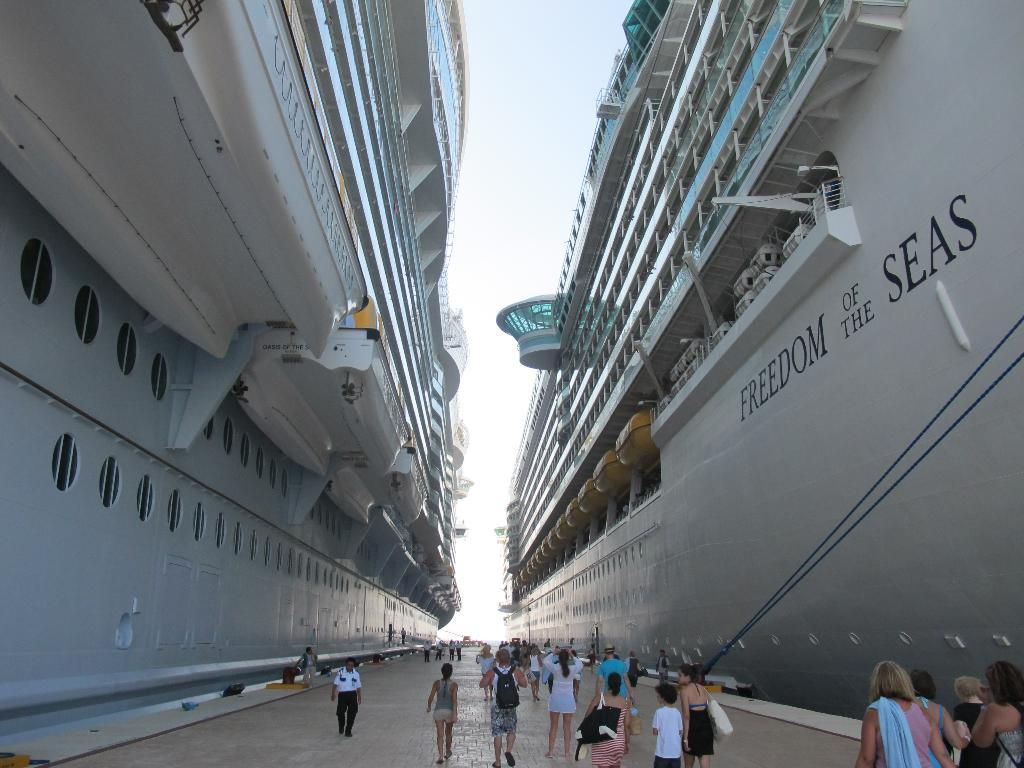<image>
Offer a succinct explanation of the picture presented. Two gigantic cruise liners are parked on a dock wit hthe one on the right having the text Freedom of the seas on its side. 